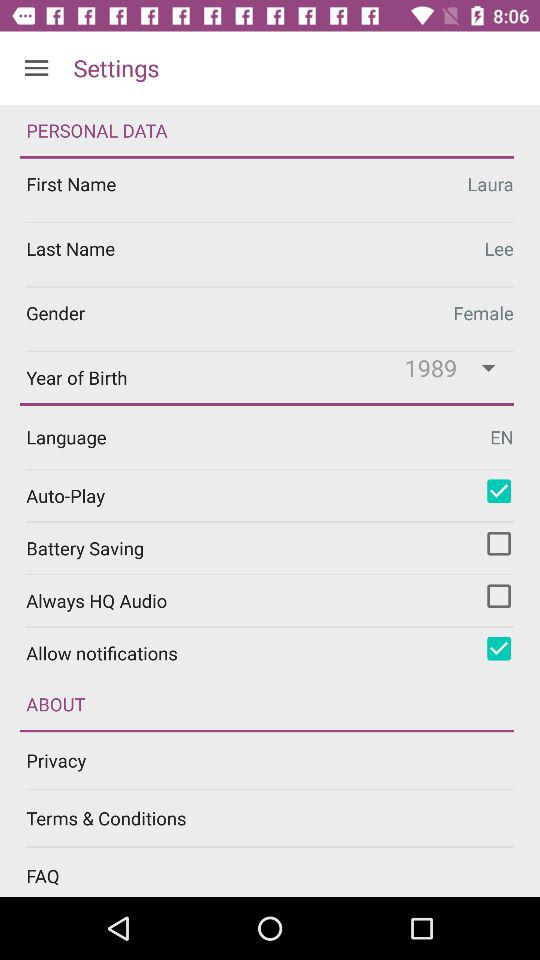What is the first name of the user? The first name of the user is Laura. 